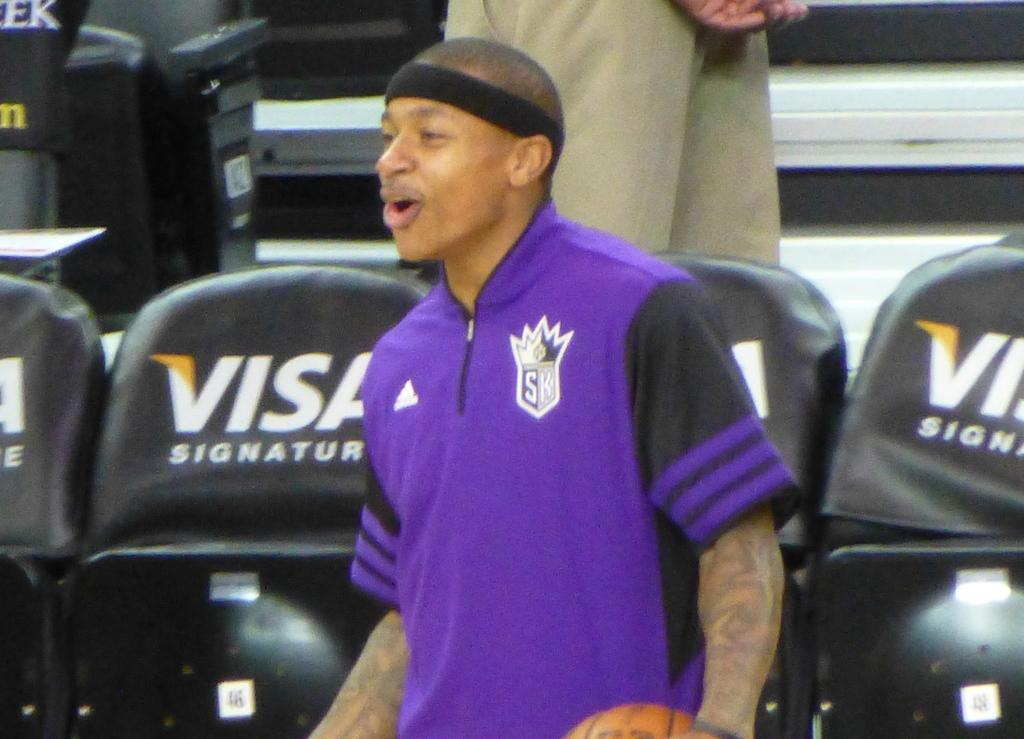<image>
Write a terse but informative summary of the picture. a man in a purple shirt is playing basketball in a place where Visa signature is advertised 